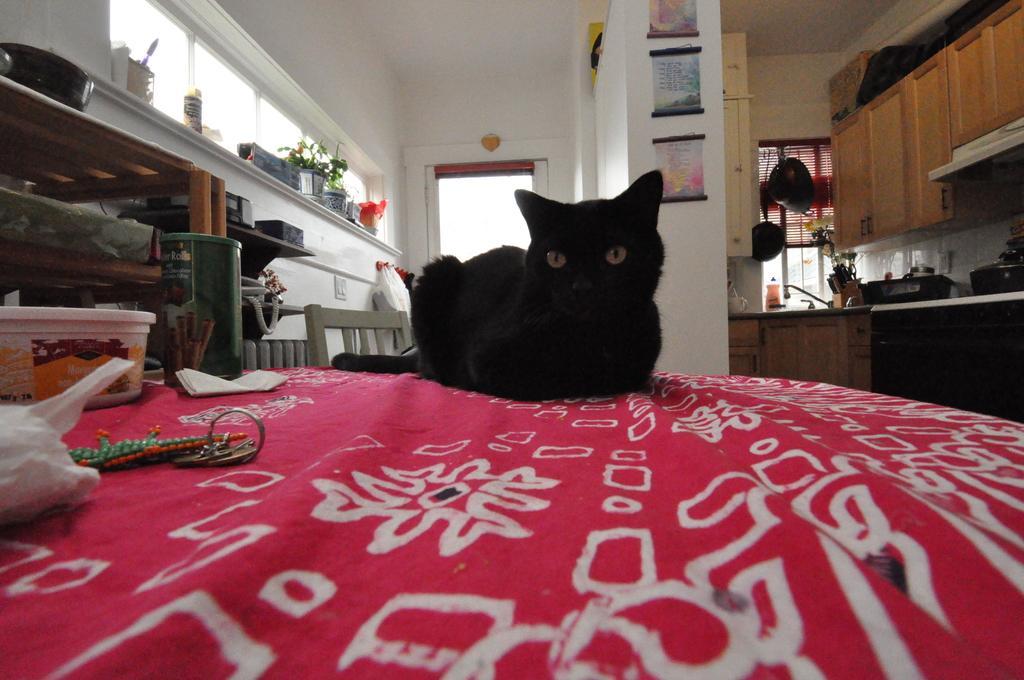Describe this image in one or two sentences. There is a red cloth with some design on that. On that there is a black cat, keychain, box, bottle and many other things. On the left side there is a cupboard with some items. Also there is a chair. On the wall there is a stand with boxes, pot with plant and many other items. In the back there is a door. Also there is a wall with something pasted on that. On the right side there are cupboards. Also there is a table with some items on that. And there is a window. On that there are some vessels hanged. 